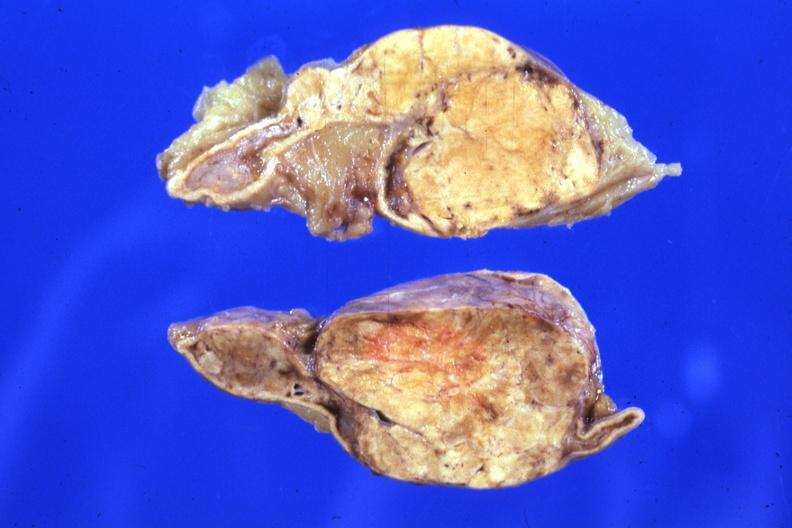what is present?
Answer the question using a single word or phrase. Adrenal 